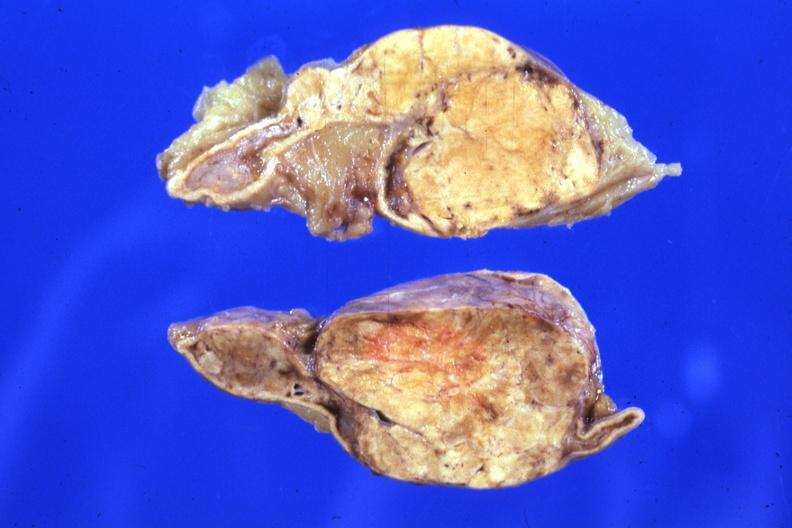what is present?
Answer the question using a single word or phrase. Adrenal 